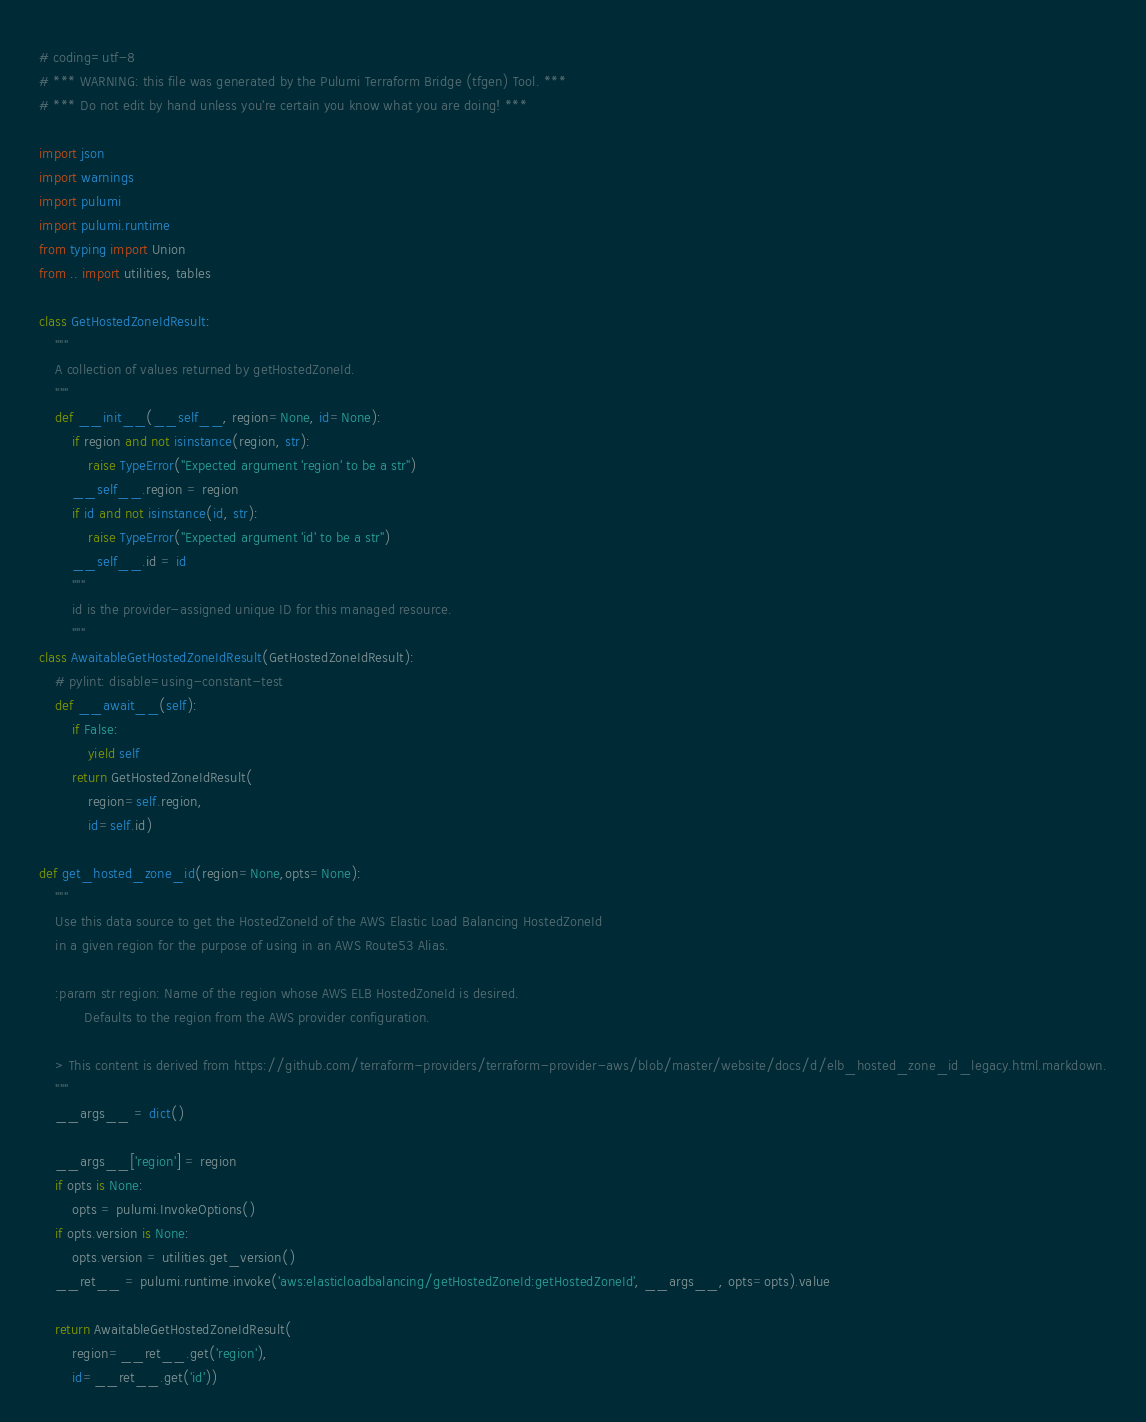Convert code to text. <code><loc_0><loc_0><loc_500><loc_500><_Python_># coding=utf-8
# *** WARNING: this file was generated by the Pulumi Terraform Bridge (tfgen) Tool. ***
# *** Do not edit by hand unless you're certain you know what you are doing! ***

import json
import warnings
import pulumi
import pulumi.runtime
from typing import Union
from .. import utilities, tables

class GetHostedZoneIdResult:
    """
    A collection of values returned by getHostedZoneId.
    """
    def __init__(__self__, region=None, id=None):
        if region and not isinstance(region, str):
            raise TypeError("Expected argument 'region' to be a str")
        __self__.region = region
        if id and not isinstance(id, str):
            raise TypeError("Expected argument 'id' to be a str")
        __self__.id = id
        """
        id is the provider-assigned unique ID for this managed resource.
        """
class AwaitableGetHostedZoneIdResult(GetHostedZoneIdResult):
    # pylint: disable=using-constant-test
    def __await__(self):
        if False:
            yield self
        return GetHostedZoneIdResult(
            region=self.region,
            id=self.id)

def get_hosted_zone_id(region=None,opts=None):
    """
    Use this data source to get the HostedZoneId of the AWS Elastic Load Balancing HostedZoneId
    in a given region for the purpose of using in an AWS Route53 Alias.
    
    :param str region: Name of the region whose AWS ELB HostedZoneId is desired.
           Defaults to the region from the AWS provider configuration.

    > This content is derived from https://github.com/terraform-providers/terraform-provider-aws/blob/master/website/docs/d/elb_hosted_zone_id_legacy.html.markdown.
    """
    __args__ = dict()

    __args__['region'] = region
    if opts is None:
        opts = pulumi.InvokeOptions()
    if opts.version is None:
        opts.version = utilities.get_version()
    __ret__ = pulumi.runtime.invoke('aws:elasticloadbalancing/getHostedZoneId:getHostedZoneId', __args__, opts=opts).value

    return AwaitableGetHostedZoneIdResult(
        region=__ret__.get('region'),
        id=__ret__.get('id'))
</code> 